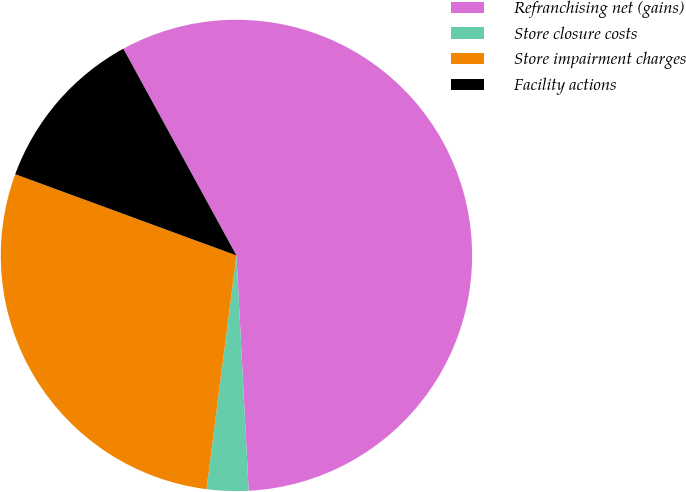<chart> <loc_0><loc_0><loc_500><loc_500><pie_chart><fcel>Refranchising net (gains)<fcel>Store closure costs<fcel>Store impairment charges<fcel>Facility actions<nl><fcel>57.14%<fcel>2.86%<fcel>28.57%<fcel>11.43%<nl></chart> 